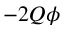<formula> <loc_0><loc_0><loc_500><loc_500>- 2 Q \phi</formula> 